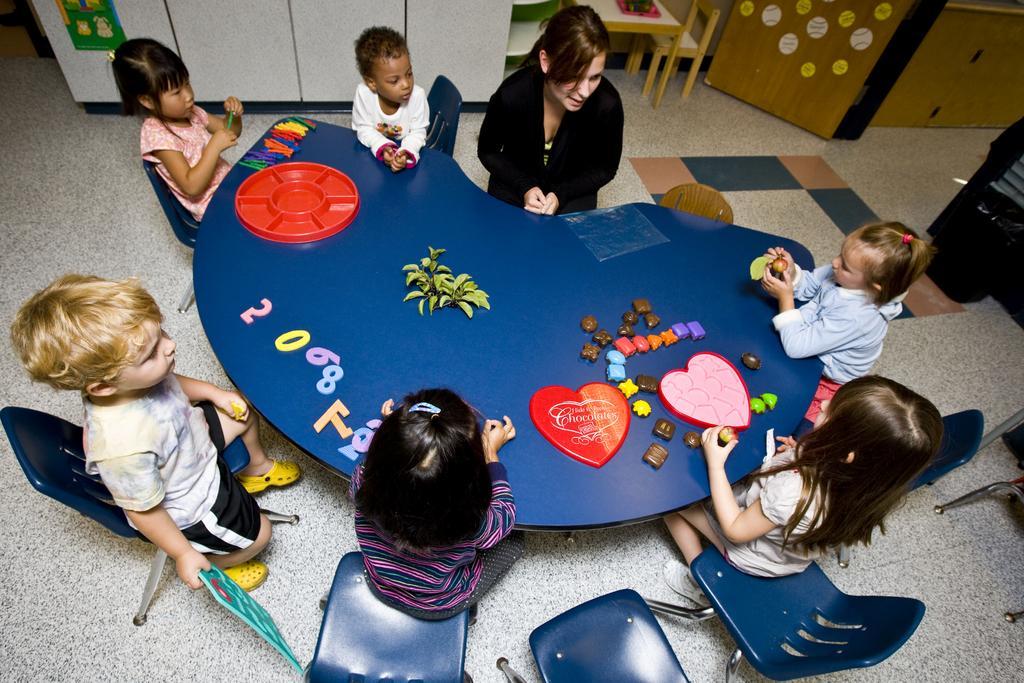Please provide a concise description of this image. In this image there are group of people sitting around a table. There are toys and plants on the table. At the back there is a table and a chair. 